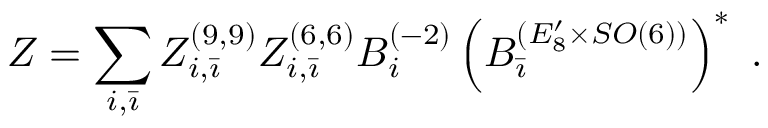<formula> <loc_0><loc_0><loc_500><loc_500>Z = \sum _ { i , \bar { \imath } } Z _ { i , \bar { \imath } } ^ { ( 9 , 9 ) } Z _ { i , \bar { \imath } } ^ { ( 6 , 6 ) } B _ { i } ^ { ( - 2 ) } \left ( B _ { \bar { \imath } } ^ { ( E _ { 8 } ^ { \prime } \times S O ( 6 ) ) } \right ) ^ { * } \, .</formula> 